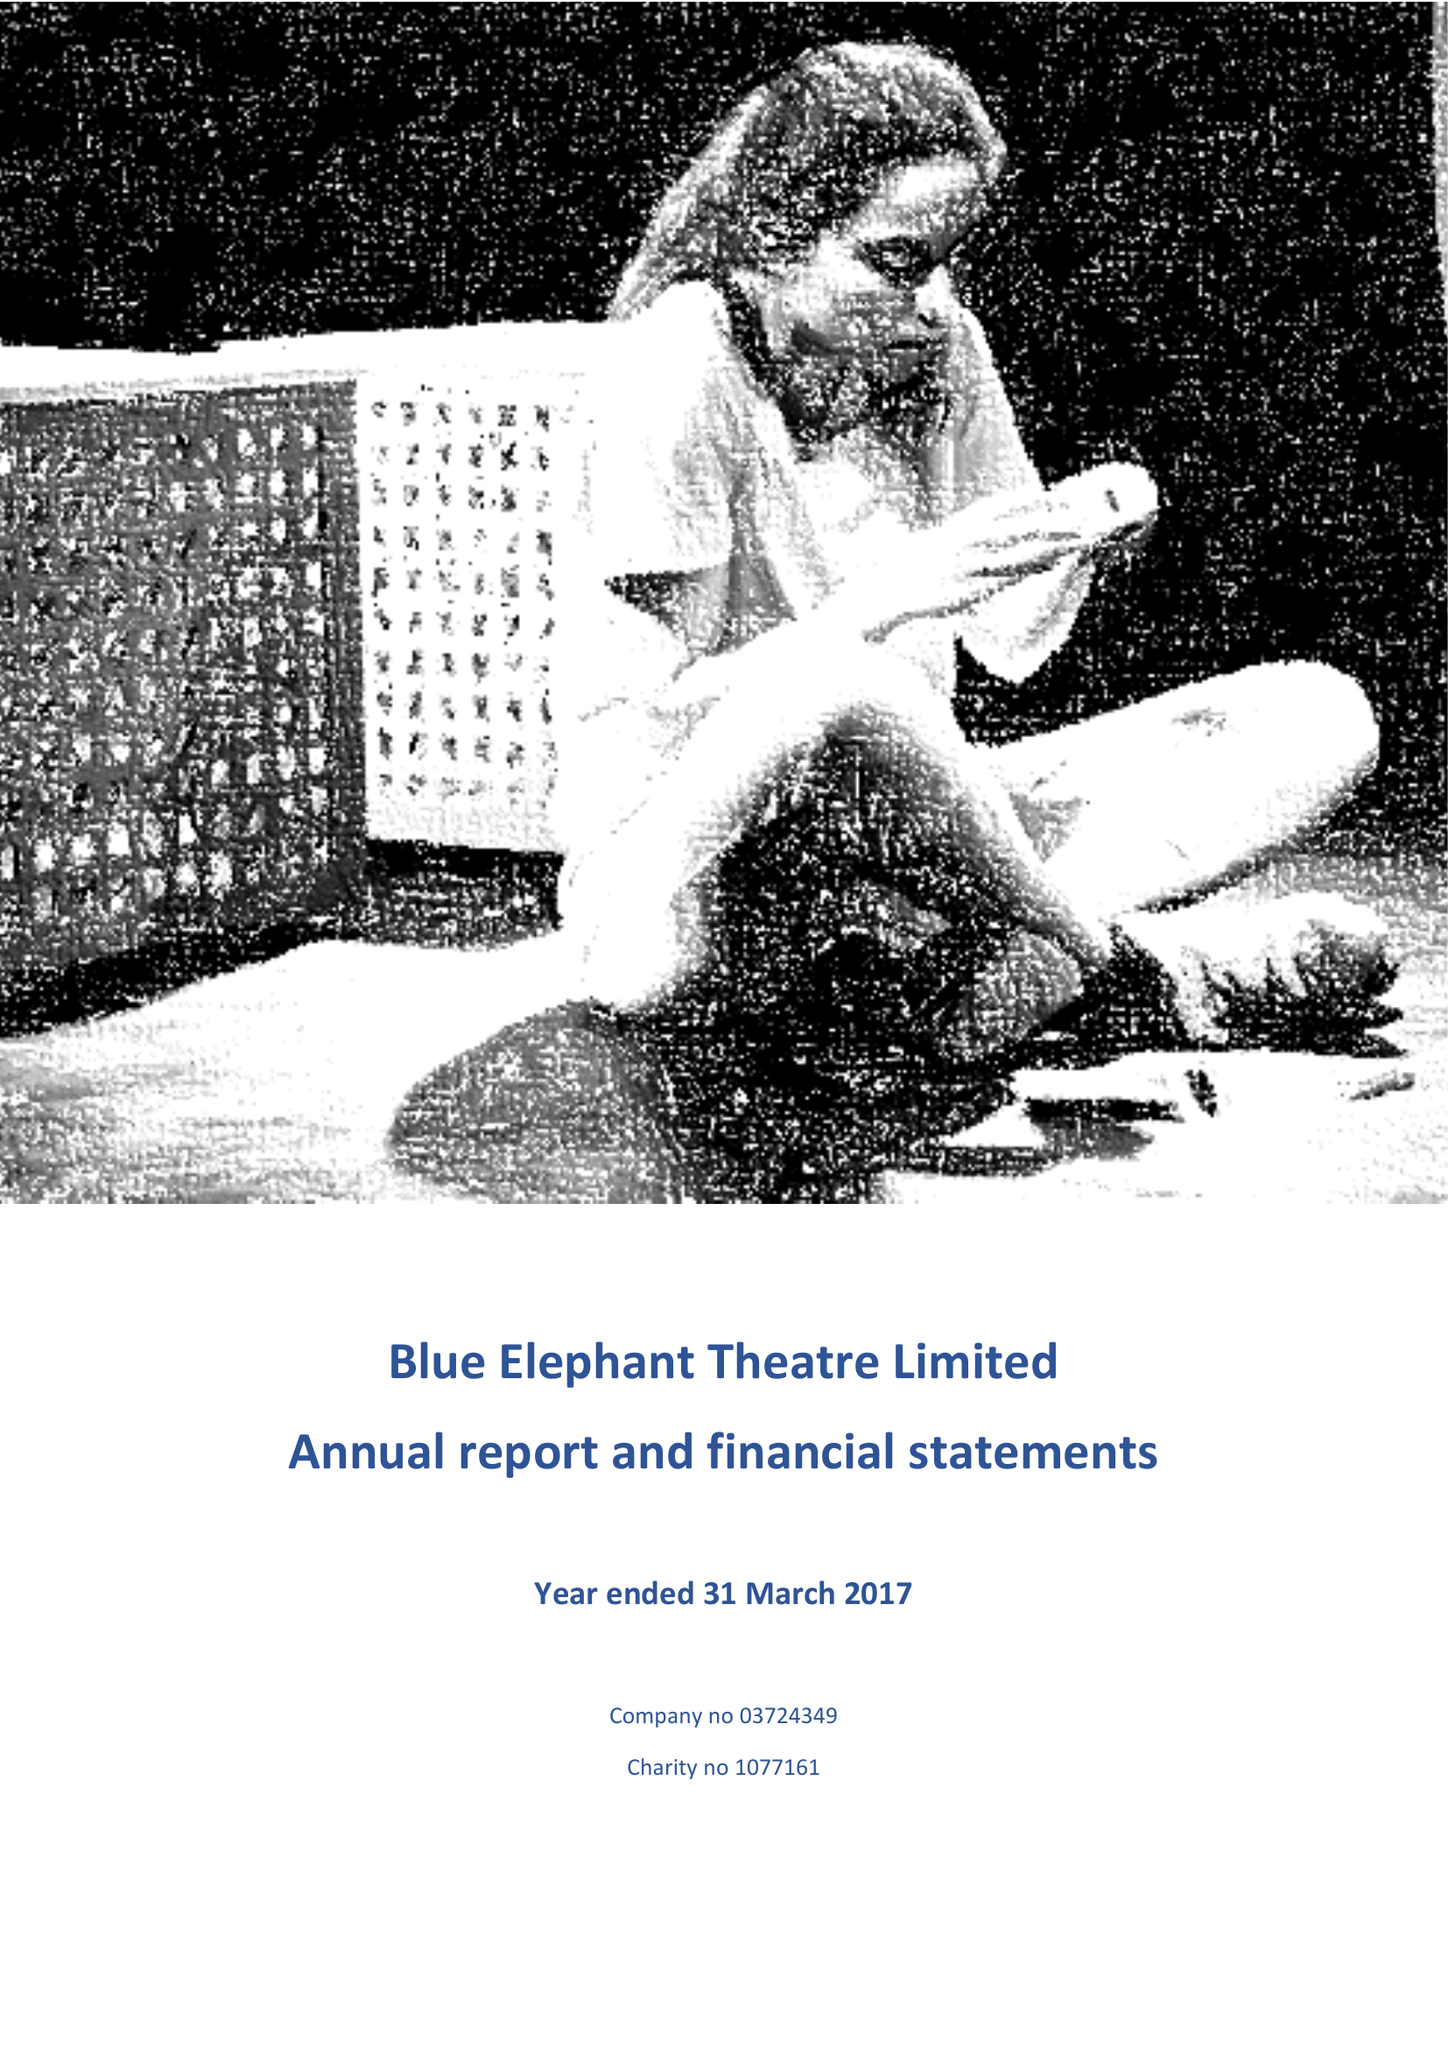What is the value for the address__post_town?
Answer the question using a single word or phrase. LONDON 